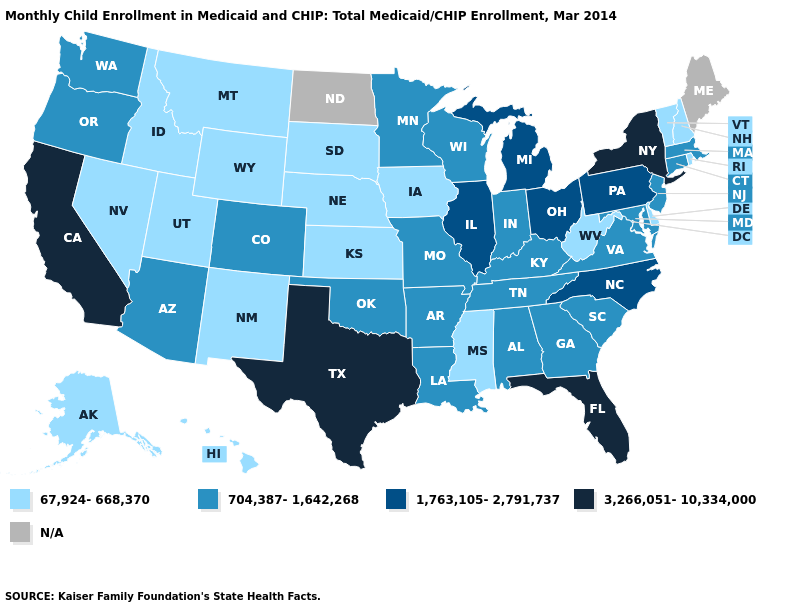What is the value of Alaska?
Give a very brief answer. 67,924-668,370. Name the states that have a value in the range 3,266,051-10,334,000?
Write a very short answer. California, Florida, New York, Texas. What is the value of Colorado?
Concise answer only. 704,387-1,642,268. What is the lowest value in the USA?
Be succinct. 67,924-668,370. Is the legend a continuous bar?
Concise answer only. No. Name the states that have a value in the range N/A?
Give a very brief answer. Maine, North Dakota. How many symbols are there in the legend?
Answer briefly. 5. Which states have the lowest value in the USA?
Concise answer only. Alaska, Delaware, Hawaii, Idaho, Iowa, Kansas, Mississippi, Montana, Nebraska, Nevada, New Hampshire, New Mexico, Rhode Island, South Dakota, Utah, Vermont, West Virginia, Wyoming. Name the states that have a value in the range 67,924-668,370?
Keep it brief. Alaska, Delaware, Hawaii, Idaho, Iowa, Kansas, Mississippi, Montana, Nebraska, Nevada, New Hampshire, New Mexico, Rhode Island, South Dakota, Utah, Vermont, West Virginia, Wyoming. Among the states that border Utah , does Colorado have the lowest value?
Keep it brief. No. Does the first symbol in the legend represent the smallest category?
Quick response, please. Yes. Does Mississippi have the lowest value in the USA?
Write a very short answer. Yes. What is the highest value in the MidWest ?
Write a very short answer. 1,763,105-2,791,737. Does Ohio have the lowest value in the USA?
Answer briefly. No. 